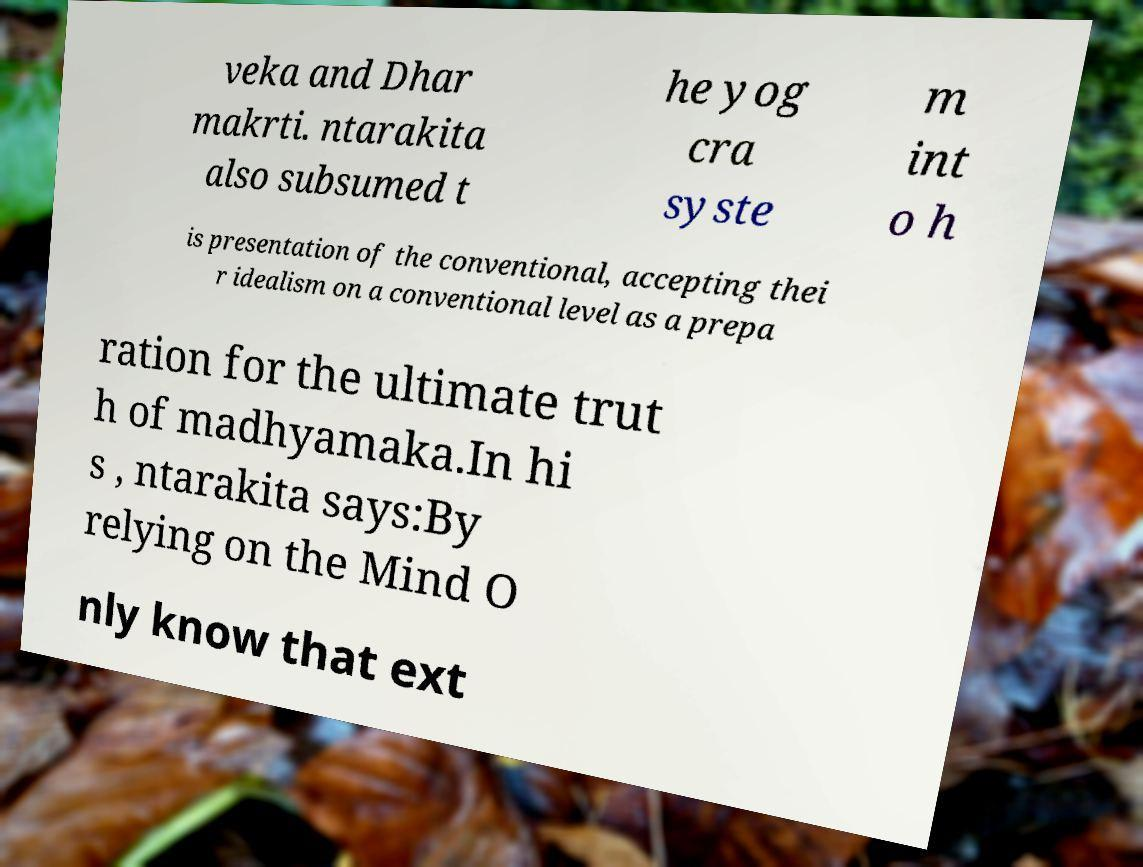Please read and relay the text visible in this image. What does it say? veka and Dhar makrti. ntarakita also subsumed t he yog cra syste m int o h is presentation of the conventional, accepting thei r idealism on a conventional level as a prepa ration for the ultimate trut h of madhyamaka.In hi s , ntarakita says:By relying on the Mind O nly know that ext 